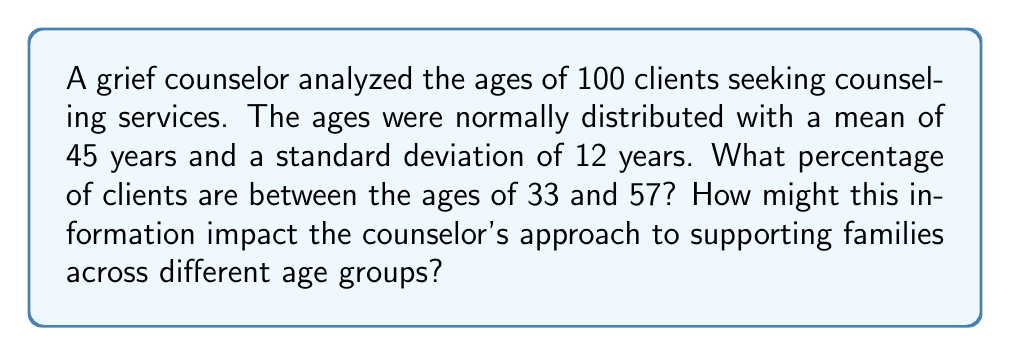Show me your answer to this math problem. 1) First, we need to calculate the z-scores for the given age range:

   For 33 years: $z_1 = \frac{33 - 45}{12} = -1$
   For 57 years: $z_2 = \frac{57 - 45}{12} = 1$

2) The problem asks for the percentage between these two z-scores. This is equivalent to finding the area under the standard normal curve between -1 and 1.

3) Using a standard normal distribution table or calculator:
   $P(-1 < Z < 1) = P(Z < 1) - P(Z < -1)$
                  $= 0.8413 - 0.1587$
                  $= 0.6826$

4) Convert to a percentage: $0.6826 \times 100\% = 68.26\%$

5) Interpretation: Approximately 68.26% of the clients seeking grief counseling services are between the ages of 33 and 57.

This information could impact the counselor's approach by highlighting the need for age-appropriate strategies and resources. The counselor might need to be prepared to address grief issues common in middle adulthood, while also having resources available for younger and older clients who fall outside this range.
Answer: 68.26% 